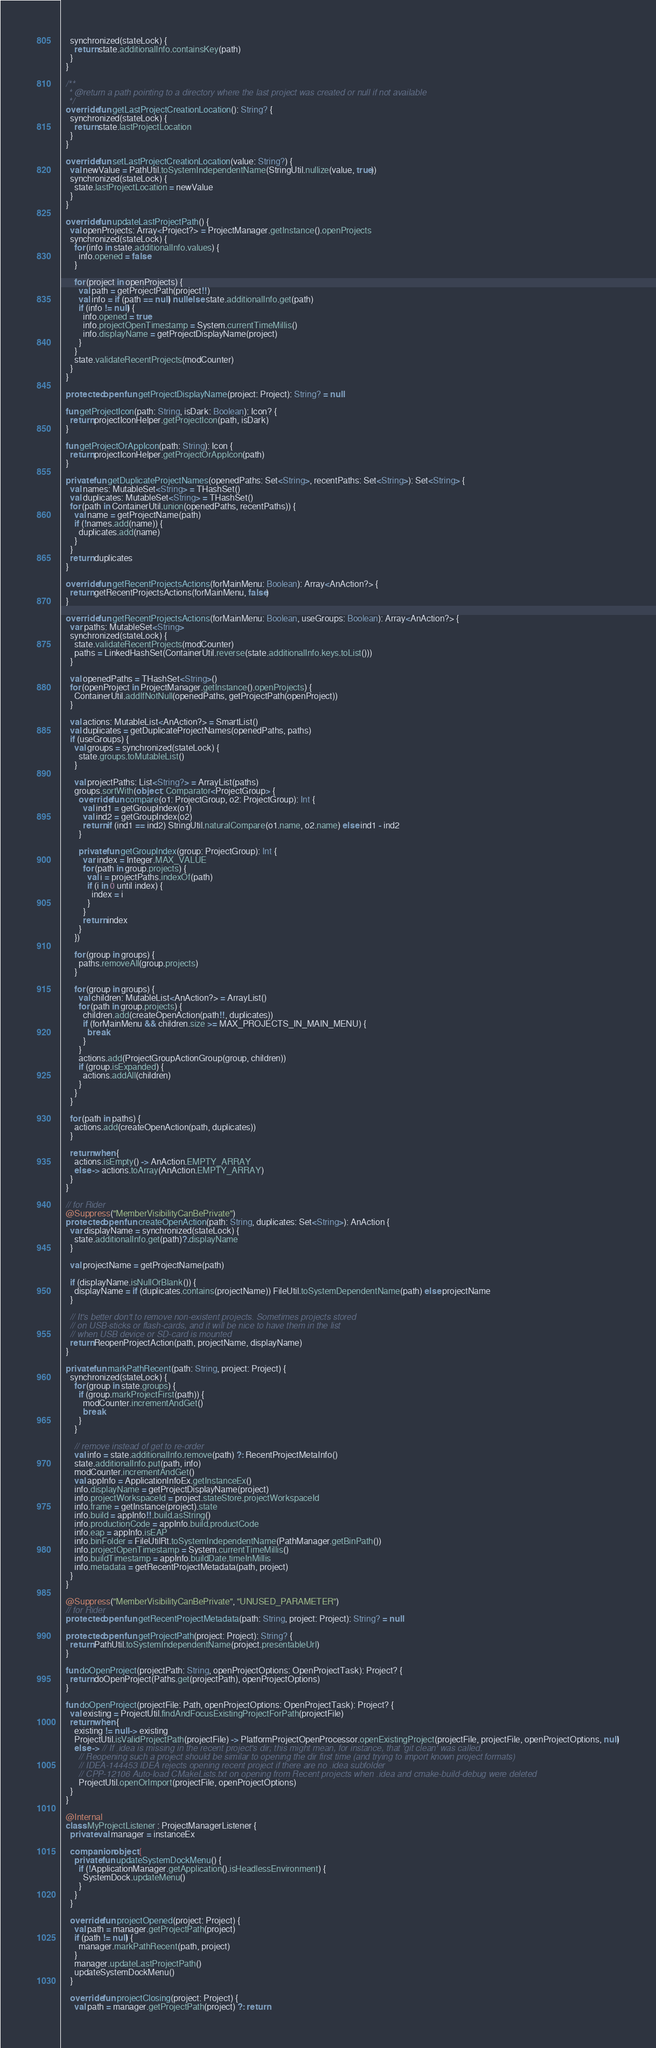<code> <loc_0><loc_0><loc_500><loc_500><_Kotlin_>    synchronized(stateLock) {
      return state.additionalInfo.containsKey(path)
    }
  }

  /**
   * @return a path pointing to a directory where the last project was created or null if not available
   */
  override fun getLastProjectCreationLocation(): String? {
    synchronized(stateLock) {
      return state.lastProjectLocation
    }
  }

  override fun setLastProjectCreationLocation(value: String?) {
    val newValue = PathUtil.toSystemIndependentName(StringUtil.nullize(value, true))
    synchronized(stateLock) {
      state.lastProjectLocation = newValue
    }
  }

  override fun updateLastProjectPath() {
    val openProjects: Array<Project?> = ProjectManager.getInstance().openProjects
    synchronized(stateLock) {
      for (info in state.additionalInfo.values) {
        info.opened = false
      }

      for (project in openProjects) {
        val path = getProjectPath(project!!)
        val info = if (path == null) null else state.additionalInfo.get(path)
        if (info != null) {
          info.opened = true
          info.projectOpenTimestamp = System.currentTimeMillis()
          info.displayName = getProjectDisplayName(project)
        }
      }
      state.validateRecentProjects(modCounter)
    }
  }

  protected open fun getProjectDisplayName(project: Project): String? = null

  fun getProjectIcon(path: String, isDark: Boolean): Icon? {
    return projectIconHelper.getProjectIcon(path, isDark)
  }

  fun getProjectOrAppIcon(path: String): Icon {
    return projectIconHelper.getProjectOrAppIcon(path)
  }

  private fun getDuplicateProjectNames(openedPaths: Set<String>, recentPaths: Set<String>): Set<String> {
    val names: MutableSet<String> = THashSet()
    val duplicates: MutableSet<String> = THashSet()
    for (path in ContainerUtil.union(openedPaths, recentPaths)) {
      val name = getProjectName(path)
      if (!names.add(name)) {
        duplicates.add(name)
      }
    }
    return duplicates
  }

  override fun getRecentProjectsActions(forMainMenu: Boolean): Array<AnAction?> {
    return getRecentProjectsActions(forMainMenu, false)
  }

  override fun getRecentProjectsActions(forMainMenu: Boolean, useGroups: Boolean): Array<AnAction?> {
    var paths: MutableSet<String>
    synchronized(stateLock) {
      state.validateRecentProjects(modCounter)
      paths = LinkedHashSet(ContainerUtil.reverse(state.additionalInfo.keys.toList()))
    }

    val openedPaths = THashSet<String>()
    for (openProject in ProjectManager.getInstance().openProjects) {
      ContainerUtil.addIfNotNull(openedPaths, getProjectPath(openProject))
    }

    val actions: MutableList<AnAction?> = SmartList()
    val duplicates = getDuplicateProjectNames(openedPaths, paths)
    if (useGroups) {
      val groups = synchronized(stateLock) {
        state.groups.toMutableList()
      }

      val projectPaths: List<String?> = ArrayList(paths)
      groups.sortWith(object : Comparator<ProjectGroup> {
        override fun compare(o1: ProjectGroup, o2: ProjectGroup): Int {
          val ind1 = getGroupIndex(o1)
          val ind2 = getGroupIndex(o2)
          return if (ind1 == ind2) StringUtil.naturalCompare(o1.name, o2.name) else ind1 - ind2
        }

        private fun getGroupIndex(group: ProjectGroup): Int {
          var index = Integer.MAX_VALUE
          for (path in group.projects) {
            val i = projectPaths.indexOf(path)
            if (i in 0 until index) {
              index = i
            }
          }
          return index
        }
      })

      for (group in groups) {
        paths.removeAll(group.projects)
      }

      for (group in groups) {
        val children: MutableList<AnAction?> = ArrayList()
        for (path in group.projects) {
          children.add(createOpenAction(path!!, duplicates))
          if (forMainMenu && children.size >= MAX_PROJECTS_IN_MAIN_MENU) {
            break
          }
        }
        actions.add(ProjectGroupActionGroup(group, children))
        if (group.isExpanded) {
          actions.addAll(children)
        }
      }
    }

    for (path in paths) {
      actions.add(createOpenAction(path, duplicates))
    }

    return when {
      actions.isEmpty() -> AnAction.EMPTY_ARRAY
      else -> actions.toArray(AnAction.EMPTY_ARRAY)
    }
  }

  // for Rider
  @Suppress("MemberVisibilityCanBePrivate")
  protected open fun createOpenAction(path: String, duplicates: Set<String>): AnAction {
    var displayName = synchronized(stateLock) {
      state.additionalInfo.get(path)?.displayName
    }

    val projectName = getProjectName(path)

    if (displayName.isNullOrBlank()) {
      displayName = if (duplicates.contains(projectName)) FileUtil.toSystemDependentName(path) else projectName
    }

    // It's better don't to remove non-existent projects. Sometimes projects stored
    // on USB-sticks or flash-cards, and it will be nice to have them in the list
    // when USB device or SD-card is mounted
    return ReopenProjectAction(path, projectName, displayName)
  }

  private fun markPathRecent(path: String, project: Project) {
    synchronized(stateLock) {
      for (group in state.groups) {
        if (group.markProjectFirst(path)) {
          modCounter.incrementAndGet()
          break
        }
      }

      // remove instead of get to re-order
      val info = state.additionalInfo.remove(path) ?: RecentProjectMetaInfo()
      state.additionalInfo.put(path, info)
      modCounter.incrementAndGet()
      val appInfo = ApplicationInfoEx.getInstanceEx()
      info.displayName = getProjectDisplayName(project)
      info.projectWorkspaceId = project.stateStore.projectWorkspaceId
      info.frame = getInstance(project).state
      info.build = appInfo!!.build.asString()
      info.productionCode = appInfo.build.productCode
      info.eap = appInfo.isEAP
      info.binFolder = FileUtilRt.toSystemIndependentName(PathManager.getBinPath())
      info.projectOpenTimestamp = System.currentTimeMillis()
      info.buildTimestamp = appInfo.buildDate.timeInMillis
      info.metadata = getRecentProjectMetadata(path, project)
    }
  }

  @Suppress("MemberVisibilityCanBePrivate", "UNUSED_PARAMETER")
  // for Rider
  protected open fun getRecentProjectMetadata(path: String, project: Project): String? = null

  protected open fun getProjectPath(project: Project): String? {
    return PathUtil.toSystemIndependentName(project.presentableUrl)
  }

  fun doOpenProject(projectPath: String, openProjectOptions: OpenProjectTask): Project? {
    return doOpenProject(Paths.get(projectPath), openProjectOptions)
  }

  fun doOpenProject(projectFile: Path, openProjectOptions: OpenProjectTask): Project? {
    val existing = ProjectUtil.findAndFocusExistingProjectForPath(projectFile)
    return when {
      existing != null -> existing
      ProjectUtil.isValidProjectPath(projectFile) -> PlatformProjectOpenProcessor.openExistingProject(projectFile, projectFile, openProjectOptions, null)
      else -> // If .idea is missing in the recent project's dir; this might mean, for instance, that 'git clean' was called.
        // Reopening such a project should be similar to opening the dir first time (and trying to import known project formats)
        // IDEA-144453 IDEA rejects opening recent project if there are no .idea subfolder
        // CPP-12106 Auto-load CMakeLists.txt on opening from Recent projects when .idea and cmake-build-debug were deleted
        ProjectUtil.openOrImport(projectFile, openProjectOptions)
    }
  }

  @Internal
  class MyProjectListener : ProjectManagerListener {
    private val manager = instanceEx

    companion object {
      private fun updateSystemDockMenu() {
        if (!ApplicationManager.getApplication().isHeadlessEnvironment) {
          SystemDock.updateMenu()
        }
      }
    }

    override fun projectOpened(project: Project) {
      val path = manager.getProjectPath(project)
      if (path != null) {
        manager.markPathRecent(path, project)
      }
      manager.updateLastProjectPath()
      updateSystemDockMenu()
    }

    override fun projectClosing(project: Project) {
      val path = manager.getProjectPath(project) ?: return</code> 